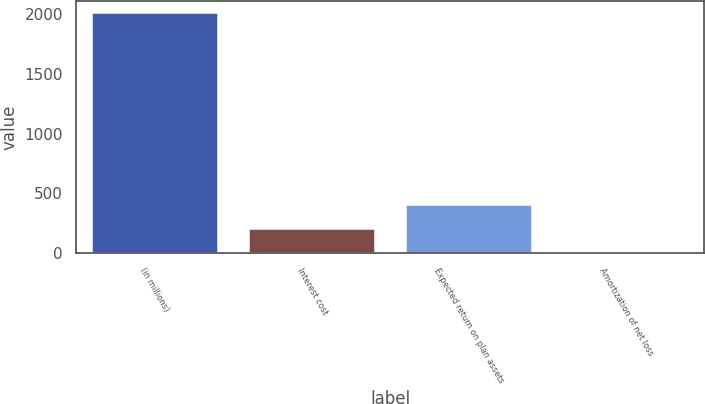<chart> <loc_0><loc_0><loc_500><loc_500><bar_chart><fcel>(in millions)<fcel>Interest cost<fcel>Expected return on plan assets<fcel>Amortization of net loss<nl><fcel>2014<fcel>202.3<fcel>403.6<fcel>1<nl></chart> 